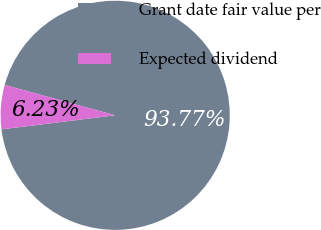<chart> <loc_0><loc_0><loc_500><loc_500><pie_chart><fcel>Grant date fair value per<fcel>Expected dividend<nl><fcel>93.77%<fcel>6.23%<nl></chart> 